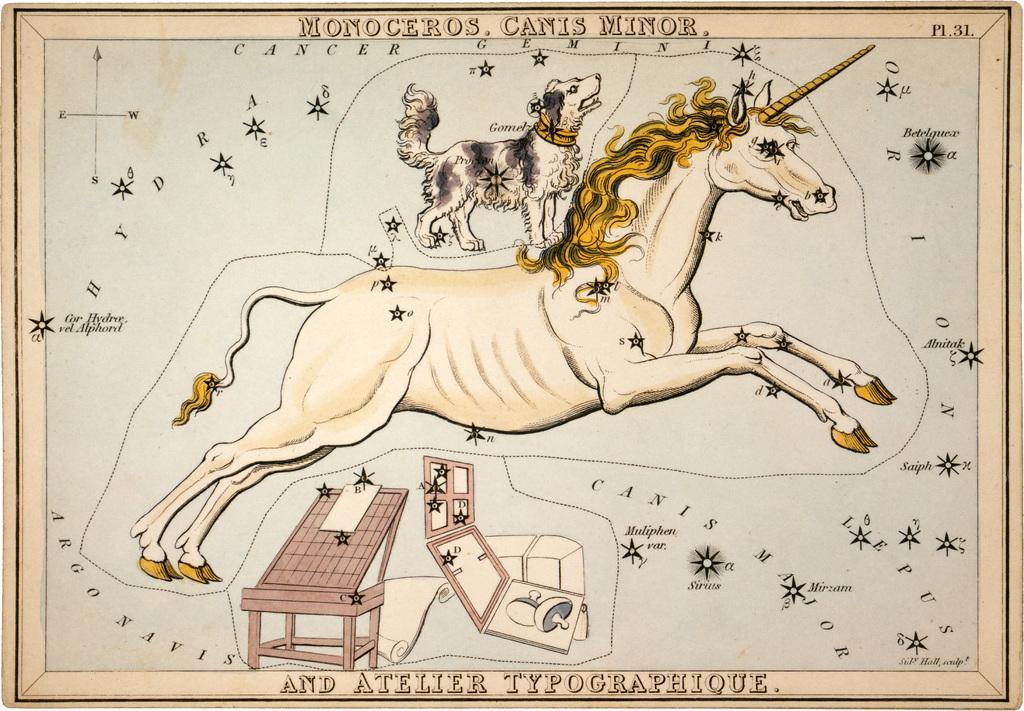Please provide a concise description of this image. In this picture we can see an object which seems to be the poster and we can see the picture of a horse and the picture of a dog and we can see the pictures of some other objects on the poster and we can see the text and numbers on the poster. 